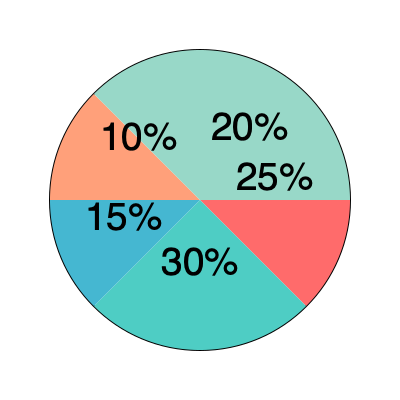Based on the pie chart showing a student's time allocation, what percentage of time should be dedicated to studying to maintain a healthy balance between academics and extracurricular activities? To determine the appropriate percentage of time for studying, we need to analyze the pie chart and consider a balanced approach to college life. Let's break down the chart:

1. The pie chart is divided into five sections, representing different activities.
2. The largest section (light blue) represents 30% of the total time.
3. The second-largest section (red) represents 25% of the total time.
4. The remaining sections represent 20%, 15%, and 10% of the time.

Given that this is a college student facing academic challenges, we can assume that the largest section (30%) should be dedicated to studying. This allocation allows for:

- Sufficient time for academic pursuits
- Adequate preparation for classes and exams
- Time for completing assignments and projects

The 30% allocation for studying also leaves room for other important aspects of college life:

- 25% for sleep and rest (essential for mental and physical well-being)
- 20% for social activities and recreation (important for personal growth and stress relief)
- 15% for extracurricular activities (valuable for skill development and networking)
- 10% for personal care and miscellaneous tasks

This distribution ensures a balanced approach to college life, addressing both academic needs and personal well-being.
Answer: 30% 